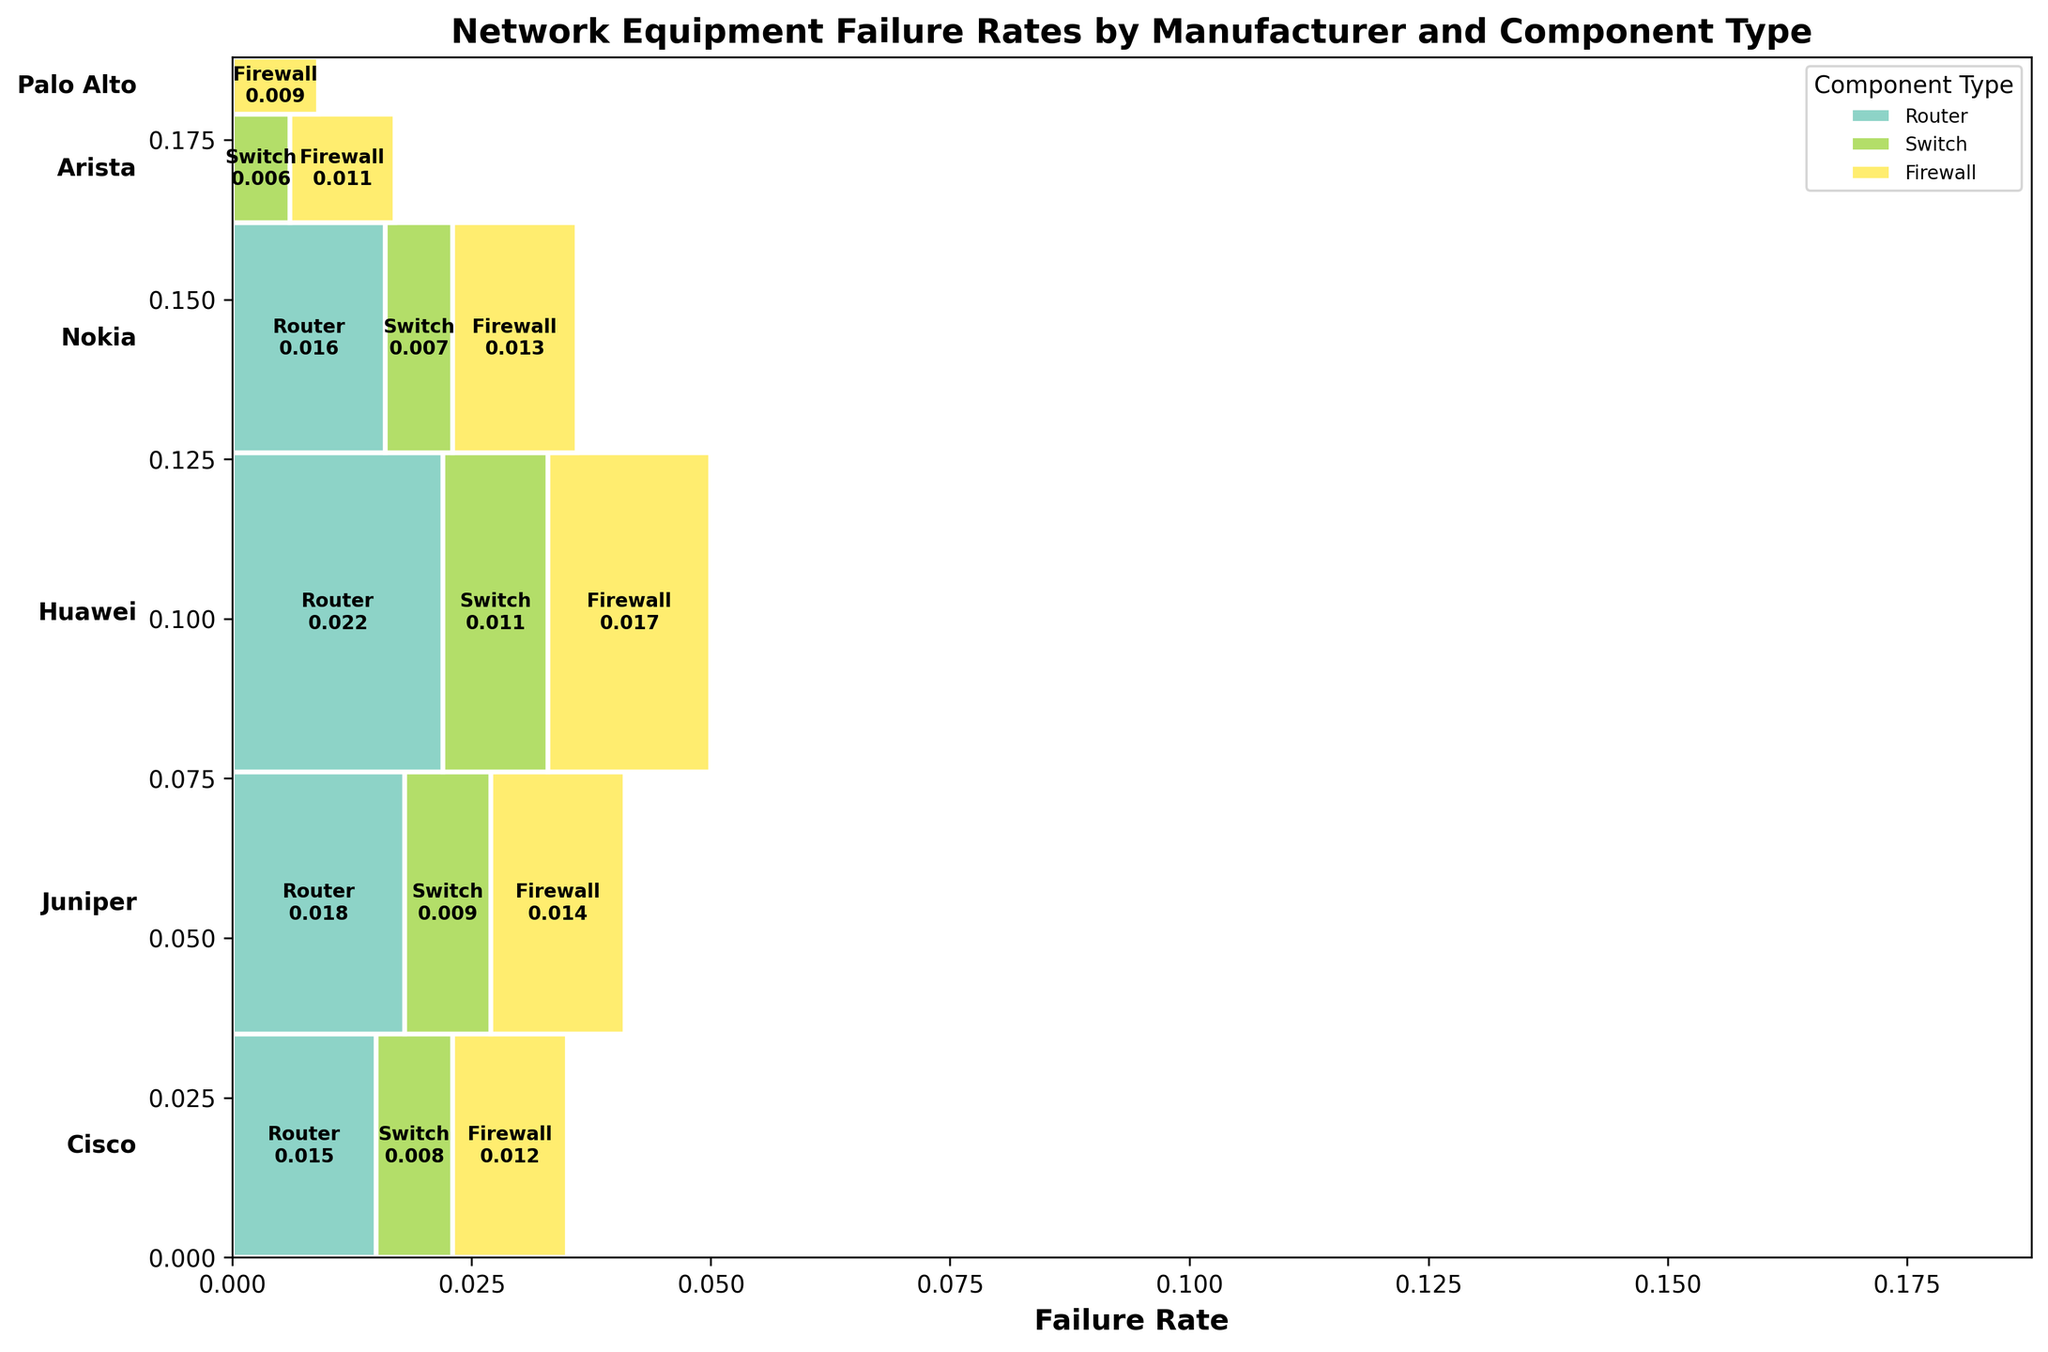What's the title of the figure? The title of the figure is located at the top and summarizes what the plot is about. Look at the central, upper part of the figure to identify it.
Answer: Network Equipment Failure Rates by Manufacturer and Component Type What is the overall failure rate for Juniper's equipment? To find the overall failure rate for Juniper, add the failure rates for the Router, Switch, and Firewall components from the Juniper section of the plot.
Answer: 0.041 Which manufacturer has the highest overall failure rate? Compare the total heights of the sections assigned to each manufacturer in the plot. The tallest section represents the manufacturer with the highest overall failure rate.
Answer: Huawei Which component type has the least failure rate for Cisco? Look at the Cisco section of the plot and compare the widths of the Router, Switch, and Firewall components. The smallest width corresponds to the component with the least failure rate.
Answer: Switch Is Palo Alto included in the analysis? Check the manufacturers listed on the left side of the plot. If Palo Alto is listed, then it is included in the analysis.
Answer: Yes What is the difference in failure rates between Huawei's Router and Nokia's Switch? Identify the widths corresponding to Huawei's Router and Nokia's Switch, then subtract the smaller width from the larger one.
Answer: 0.015 Which component and manufacturer combination has the lowest failure rate? Find the narrowest rectangle section in all manufacturers' components in the plot, which represents the lowest failure rate combination.
Answer: Arista Switch Compare the failure rates of Cisco and Juniper Routers. Which one is higher? Locate the Cisco and Juniper sections and compare the widths of their respective Router components. The wider one has a higher failure rate.
Answer: Juniper What percentage of the total failure rate does the Cisco Switch represent within Cisco's section? Calculate the total failure rate for Cisco by summing its components' failure rates. Then, divide the Switch failure rate by this total and multiply by 100 to get the percentage.
Answer: 23.5% How many different component types are analyzed in this figure? Count the distinct component types, such as Router, Switch, and Firewall, labeled within the plot.
Answer: 3 